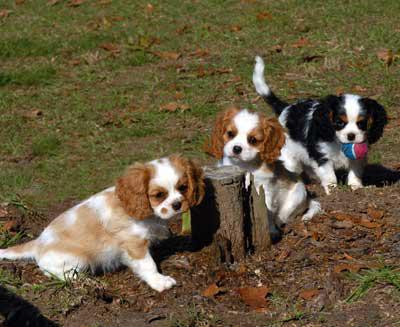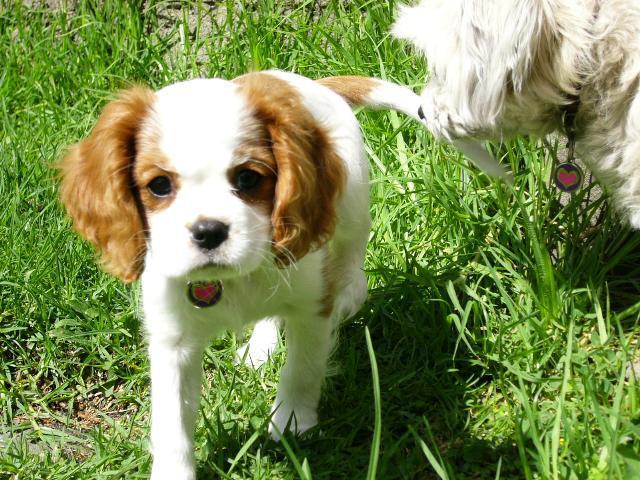The first image is the image on the left, the second image is the image on the right. For the images shown, is this caption "A spaniel puppy is posed on its belly on wood planks, in one image." true? Answer yes or no. No. The first image is the image on the left, the second image is the image on the right. Assess this claim about the two images: "There are no less than two brown and white dogs and no less than one dog of a different color than the brown and white ones". Correct or not? Answer yes or no. Yes. 